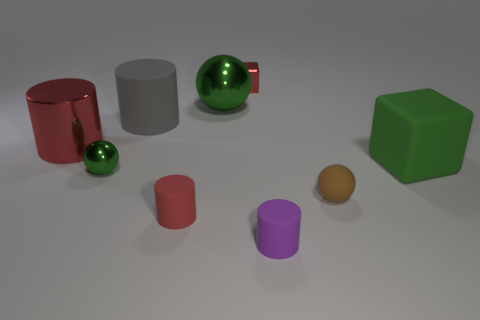How many other things are the same color as the small cube?
Your response must be concise. 2. Does the purple rubber object have the same size as the red thing in front of the brown object?
Your response must be concise. Yes. There is a sphere that is on the right side of the red metal block; is its size the same as the tiny red cube?
Ensure brevity in your answer.  Yes. What number of other things are made of the same material as the brown object?
Ensure brevity in your answer.  4. Is the number of red things on the left side of the small green ball the same as the number of large gray cylinders in front of the gray thing?
Your response must be concise. No. There is a small shiny object to the left of the red thing in front of the sphere that is on the right side of the red metallic block; what color is it?
Offer a terse response. Green. There is a small red thing in front of the small red metal cube; what shape is it?
Provide a short and direct response. Cylinder. What is the shape of the tiny green thing that is the same material as the large red cylinder?
Provide a short and direct response. Sphere. Are there any other things that are the same shape as the small purple object?
Keep it short and to the point. Yes. There is a big red cylinder; how many small things are in front of it?
Offer a terse response. 4. 